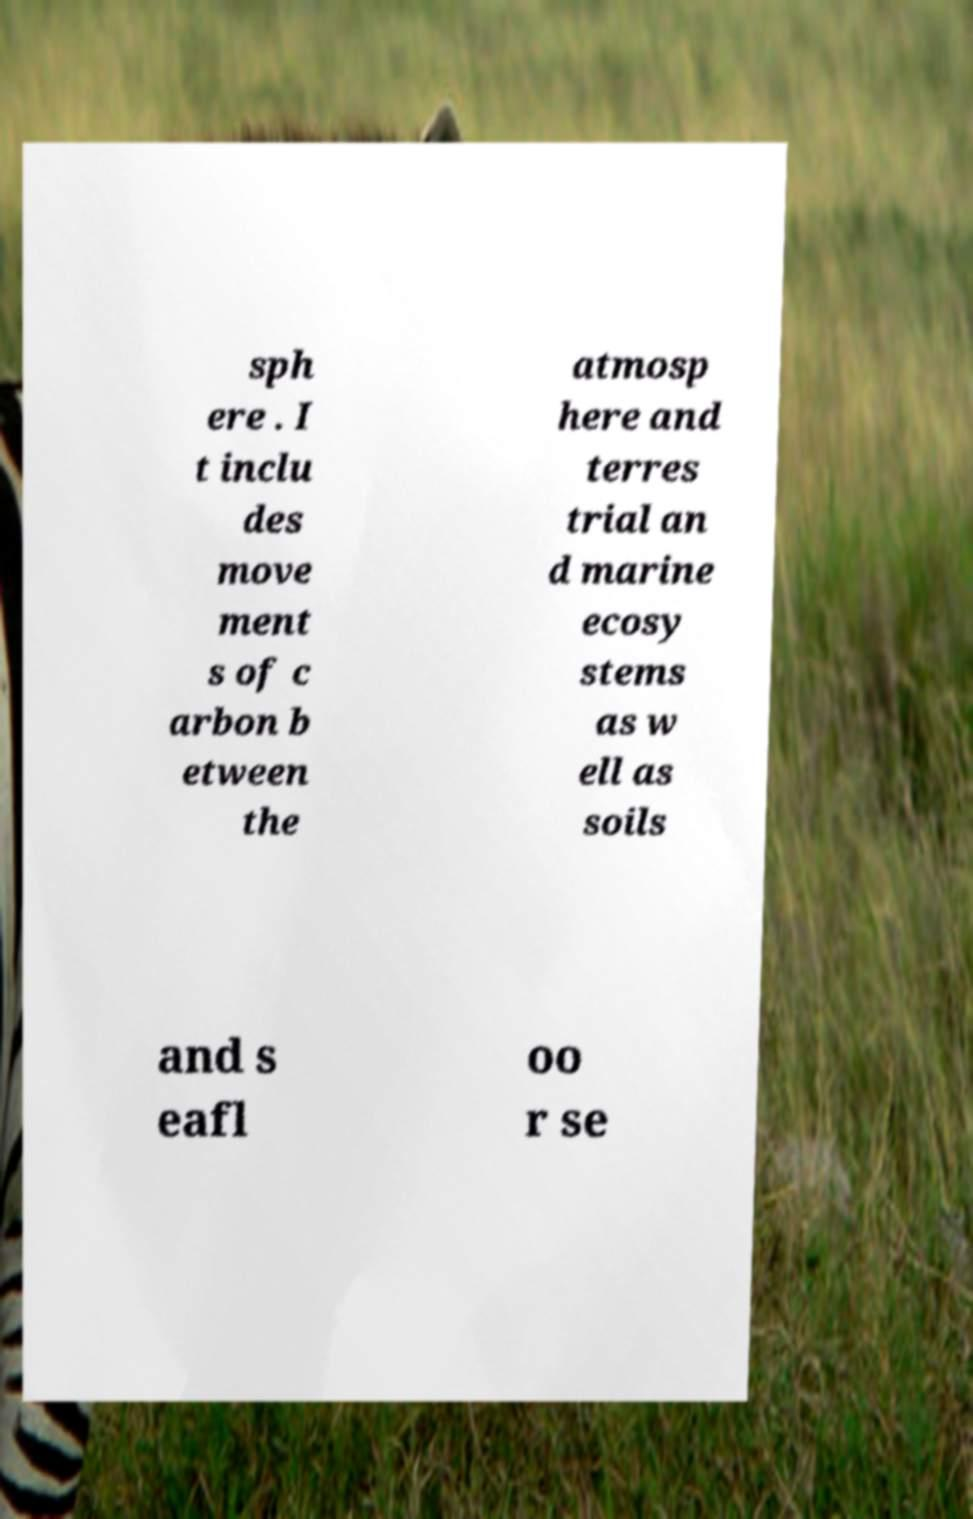I need the written content from this picture converted into text. Can you do that? sph ere . I t inclu des move ment s of c arbon b etween the atmosp here and terres trial an d marine ecosy stems as w ell as soils and s eafl oo r se 